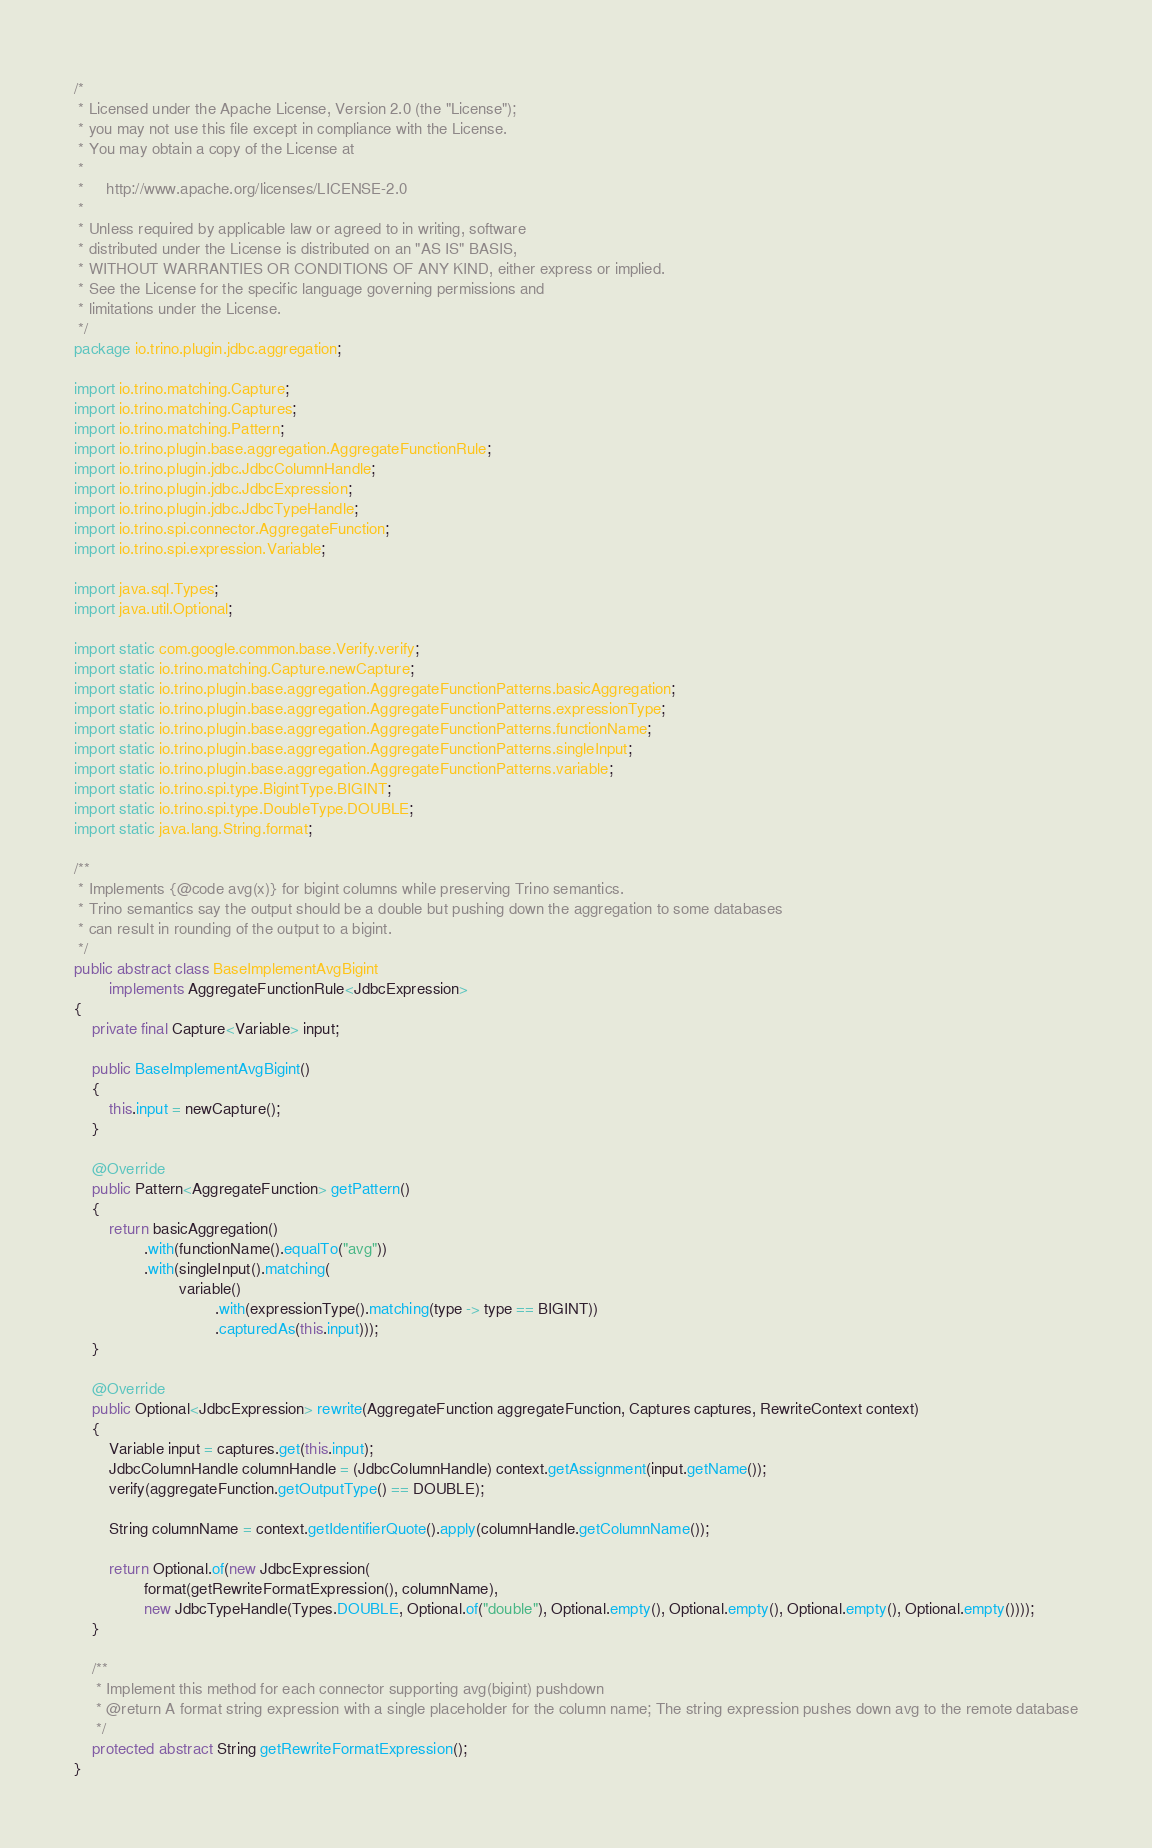Convert code to text. <code><loc_0><loc_0><loc_500><loc_500><_Java_>/*
 * Licensed under the Apache License, Version 2.0 (the "License");
 * you may not use this file except in compliance with the License.
 * You may obtain a copy of the License at
 *
 *     http://www.apache.org/licenses/LICENSE-2.0
 *
 * Unless required by applicable law or agreed to in writing, software
 * distributed under the License is distributed on an "AS IS" BASIS,
 * WITHOUT WARRANTIES OR CONDITIONS OF ANY KIND, either express or implied.
 * See the License for the specific language governing permissions and
 * limitations under the License.
 */
package io.trino.plugin.jdbc.aggregation;

import io.trino.matching.Capture;
import io.trino.matching.Captures;
import io.trino.matching.Pattern;
import io.trino.plugin.base.aggregation.AggregateFunctionRule;
import io.trino.plugin.jdbc.JdbcColumnHandle;
import io.trino.plugin.jdbc.JdbcExpression;
import io.trino.plugin.jdbc.JdbcTypeHandle;
import io.trino.spi.connector.AggregateFunction;
import io.trino.spi.expression.Variable;

import java.sql.Types;
import java.util.Optional;

import static com.google.common.base.Verify.verify;
import static io.trino.matching.Capture.newCapture;
import static io.trino.plugin.base.aggregation.AggregateFunctionPatterns.basicAggregation;
import static io.trino.plugin.base.aggregation.AggregateFunctionPatterns.expressionType;
import static io.trino.plugin.base.aggregation.AggregateFunctionPatterns.functionName;
import static io.trino.plugin.base.aggregation.AggregateFunctionPatterns.singleInput;
import static io.trino.plugin.base.aggregation.AggregateFunctionPatterns.variable;
import static io.trino.spi.type.BigintType.BIGINT;
import static io.trino.spi.type.DoubleType.DOUBLE;
import static java.lang.String.format;

/**
 * Implements {@code avg(x)} for bigint columns while preserving Trino semantics.
 * Trino semantics say the output should be a double but pushing down the aggregation to some databases
 * can result in rounding of the output to a bigint.
 */
public abstract class BaseImplementAvgBigint
        implements AggregateFunctionRule<JdbcExpression>
{
    private final Capture<Variable> input;

    public BaseImplementAvgBigint()
    {
        this.input = newCapture();
    }

    @Override
    public Pattern<AggregateFunction> getPattern()
    {
        return basicAggregation()
                .with(functionName().equalTo("avg"))
                .with(singleInput().matching(
                        variable()
                                .with(expressionType().matching(type -> type == BIGINT))
                                .capturedAs(this.input)));
    }

    @Override
    public Optional<JdbcExpression> rewrite(AggregateFunction aggregateFunction, Captures captures, RewriteContext context)
    {
        Variable input = captures.get(this.input);
        JdbcColumnHandle columnHandle = (JdbcColumnHandle) context.getAssignment(input.getName());
        verify(aggregateFunction.getOutputType() == DOUBLE);

        String columnName = context.getIdentifierQuote().apply(columnHandle.getColumnName());

        return Optional.of(new JdbcExpression(
                format(getRewriteFormatExpression(), columnName),
                new JdbcTypeHandle(Types.DOUBLE, Optional.of("double"), Optional.empty(), Optional.empty(), Optional.empty(), Optional.empty())));
    }

    /**
     * Implement this method for each connector supporting avg(bigint) pushdown
     * @return A format string expression with a single placeholder for the column name; The string expression pushes down avg to the remote database
     */
    protected abstract String getRewriteFormatExpression();
}
</code> 